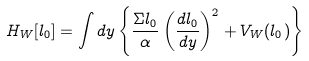Convert formula to latex. <formula><loc_0><loc_0><loc_500><loc_500>H _ { W } [ l _ { 0 } ] = \int d y \left \{ \frac { \Sigma l _ { 0 } } { \alpha } \left ( \frac { d l _ { 0 } } { d y } \right ) ^ { 2 } + V _ { W } ( l _ { 0 } ) \right \}</formula> 